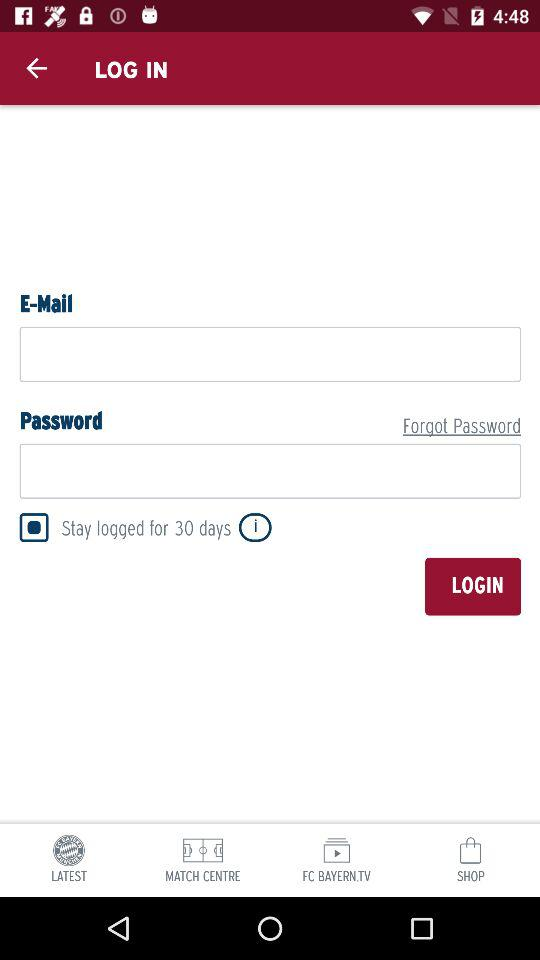For how many days can the user stay logged in? The user can stay logged in for 30 days. 